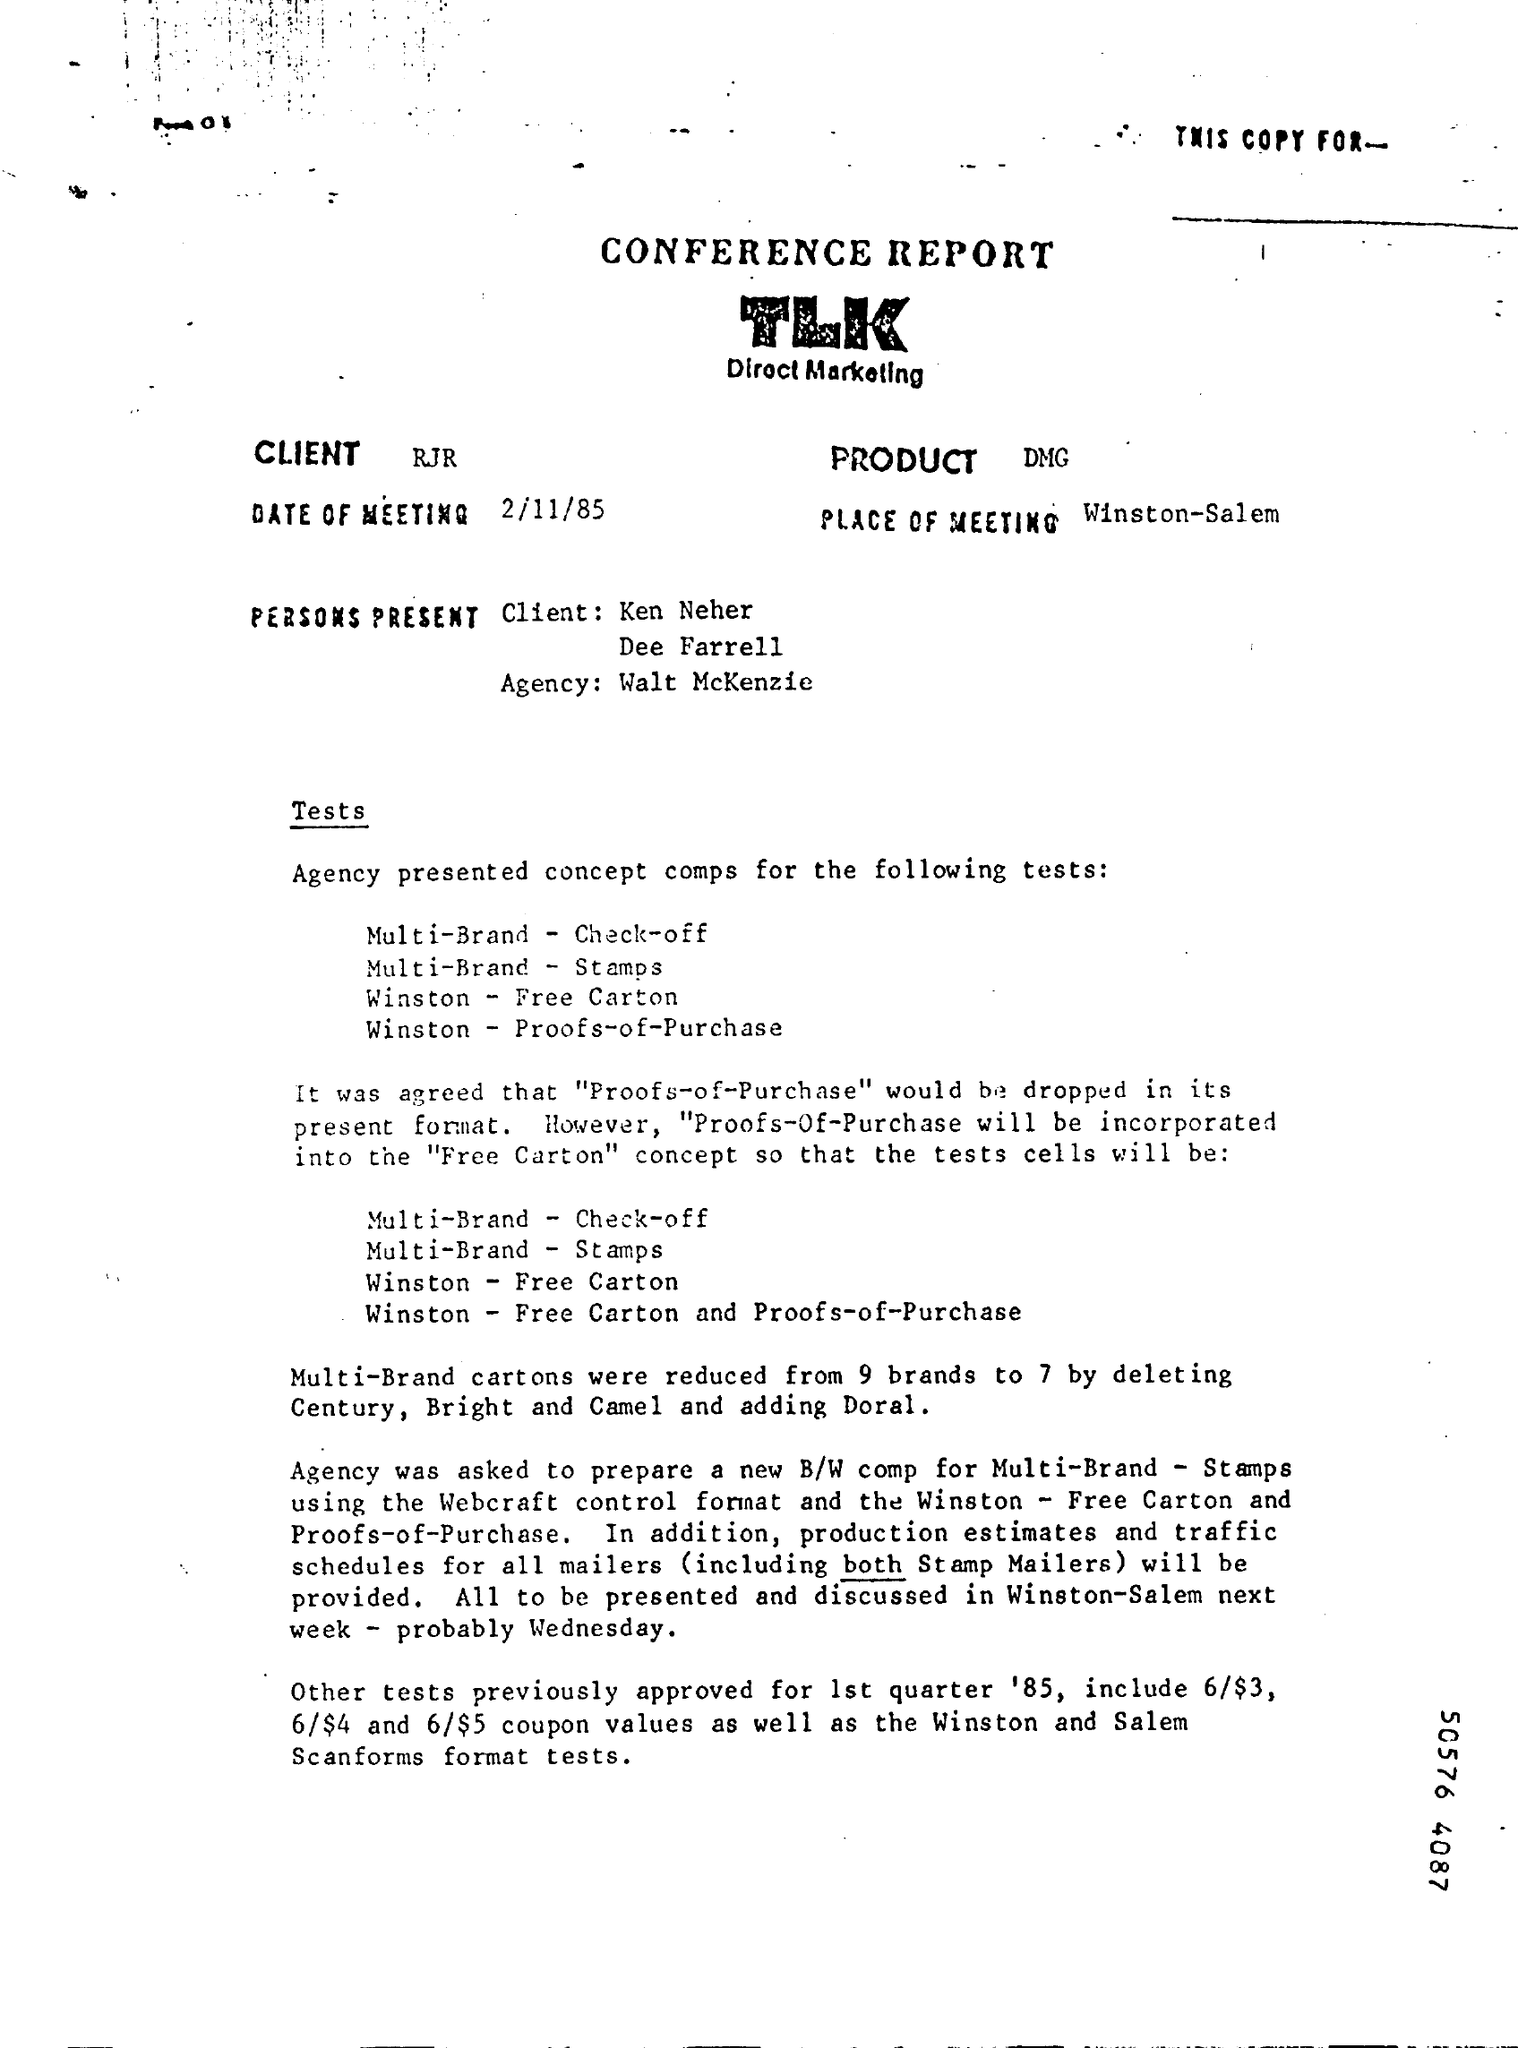List a handful of essential elements in this visual. The place of the meeting is Winston-Salem. The meeting was held on February 11, 1985. We have successfully reduced the number of multi-brand cartons from 9 brands to 7, resulting in a more organized and efficient supply chain. It was decided during the meeting that "Proofs-of-Purchase" will be incorporated into the concept of free cartons. 